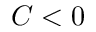<formula> <loc_0><loc_0><loc_500><loc_500>C < 0</formula> 